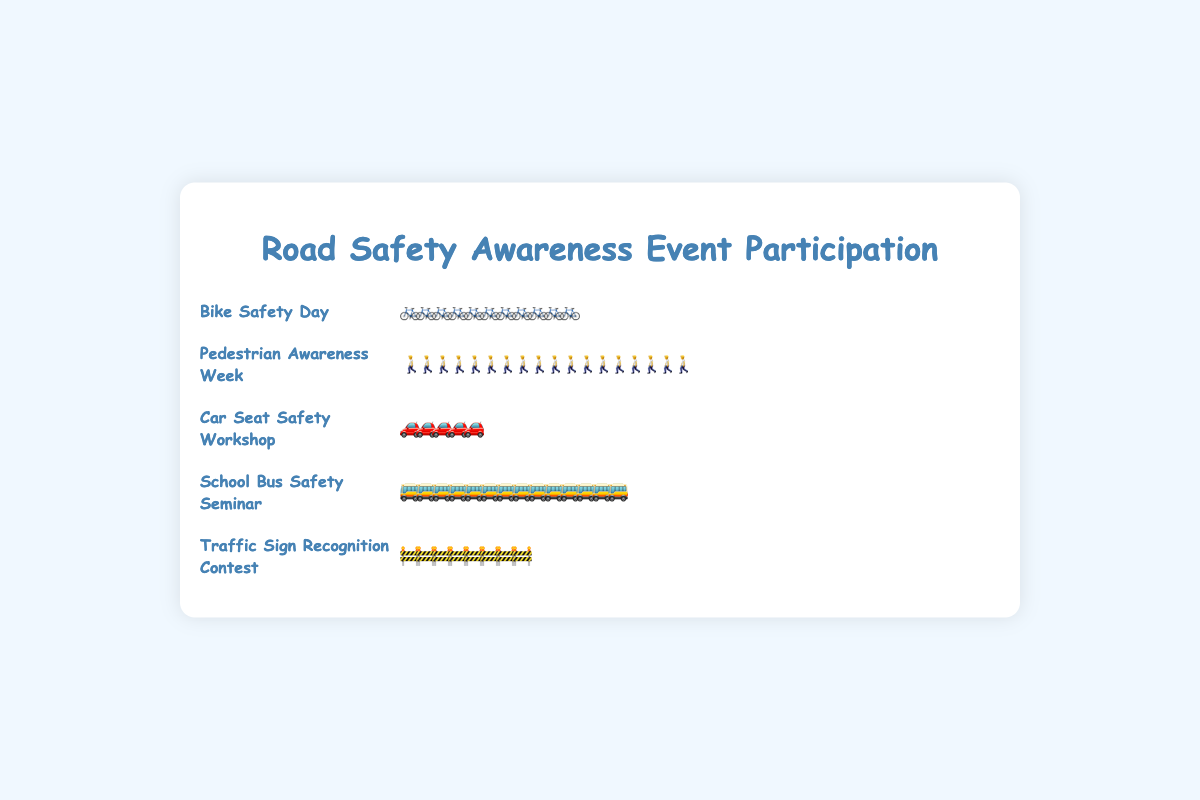Which event had the highest participation rate? By looking at the icons, "Pedestrian Awareness Week" has the most icons representing the participants, indicating it has the highest participation rate.
Answer: Pedestrian Awareness Week Which event had the fewest participants? The "Car Seat Safety Workshop" has the fewest icons, which means it had the fewest participants.
Answer: Car Seat Safety Workshop How many participants attended the "School Bus Safety Seminar"? Count the icons next to the "School Bus Safety Seminar". Each icon roughly represents 25 participants. There are 14 icons. So, the number of participants is 14 * 25 = 350.
Answer: 350 What is the difference in participation between "Bike Safety Day" and "Car Seat Safety Workshop"? "Bike Safety Day" has 11 icons and "Car Seat Safety Workshop" has 5 icons. Each icon represents about 25 participants. The difference is (11 - 5) * 25 = 150.
Answer: 150 Which event attracted more participants, "Traffic Sign Recognition Contest" or "School Bus Safety Seminar"? Compare the number of icons: "Traffic Sign Recognition Contest" has 8 icons and "School Bus Safety Seminar" has 14 icons. Thus, "School Bus Safety Seminar" attracted more participants.
Answer: School Bus Safety Seminar Arrange the events in ascending order based on participation. Look at the number of icons for each event and arrange them: "Car Seat Safety Workshop" (5), "Traffic Sign Recognition Contest" (8), "Bike Safety Day" (11), "School Bus Safety Seminar" (14), "Pedestrian Awareness Week" (18).
Answer: Car Seat Safety Workshop, Traffic Sign Recognition Contest, Bike Safety Day, School Bus Safety Seminar, Pedestrian Awareness Week What is the average number of participants across all events? Sum the total participation across all events and divide by the number of events. (280 + 450 + 120 + 350 + 200) / 5 = 1400 / 5 = 280.
Answer: 280 How many participants are represented by each icon? Divide the participation number by the number of icons for any event. For example, for "Bike Safety Day": 280 / 11 ≈ 25. So each icon represents about 25 participants.
Answer: 25 Does the "Traffic Sign Recognition Contest" have more participants than "Bike Safety Day"? Compare the number of icons: "Traffic Sign Recognition Contest" has 8 icons and "Bike Safety Day" has 11 icons. Therefore, "Bike Safety Day" has more participants.
Answer: No 